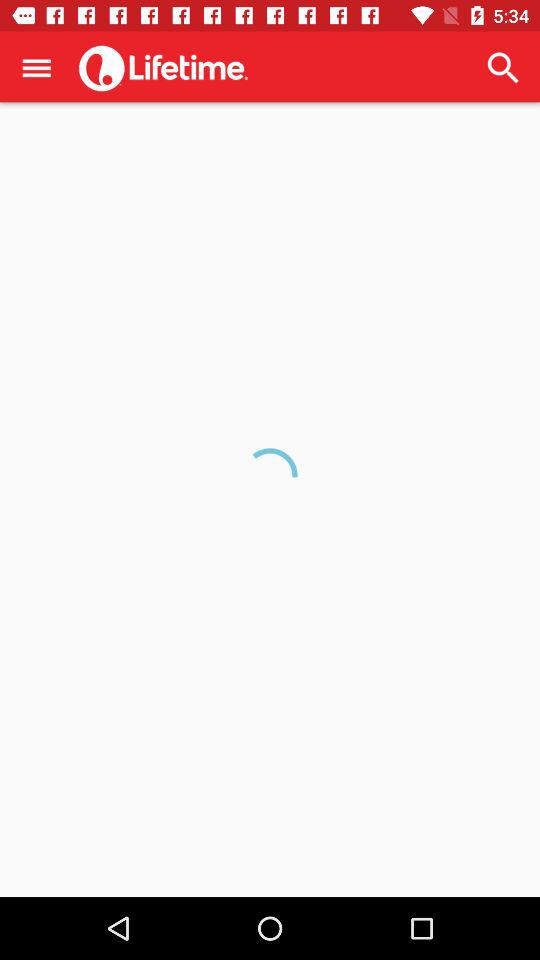What is the application name? The application name is "Lifetime". 